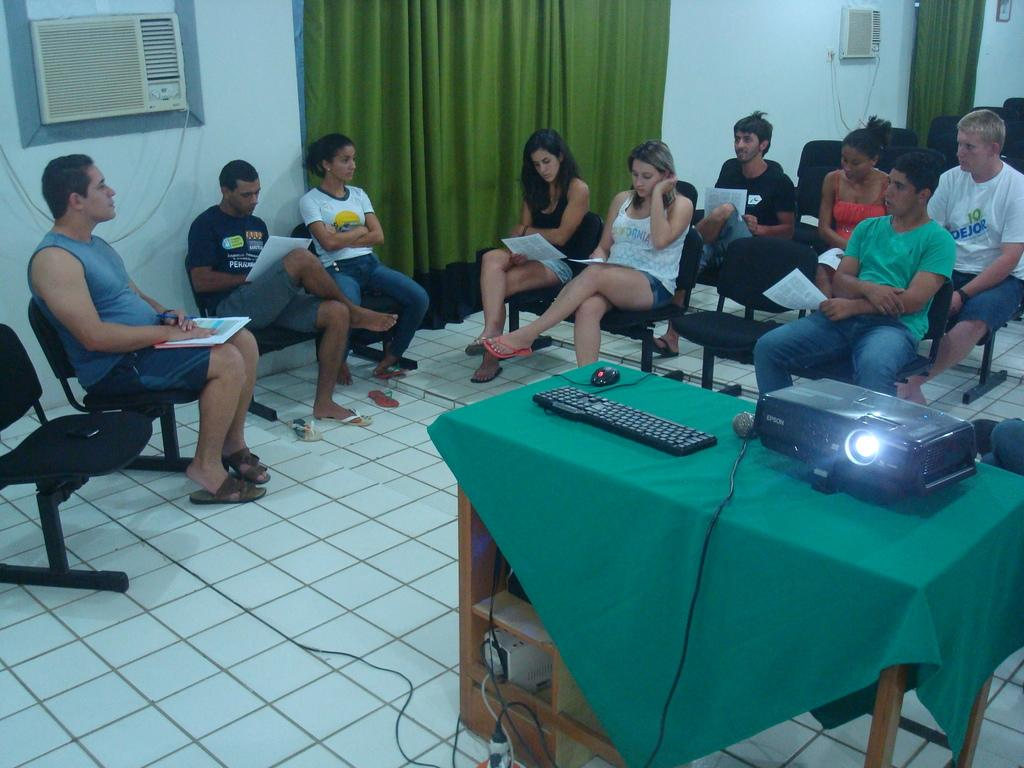What are the people in the image doing? The people in the image are sitting. What object can be seen on a table in the image? There is a projector on a table in the image. What time of day is it in the image? The provided facts do not mention the time of day, so it cannot be determined from the image. 